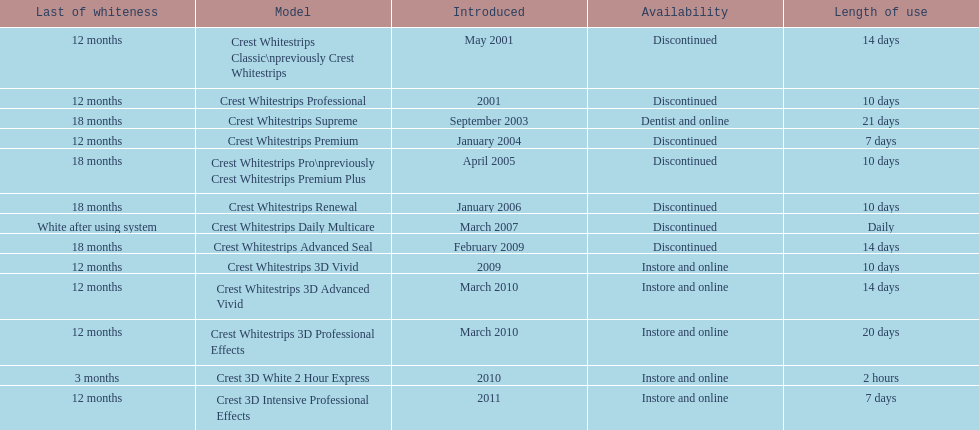How many products have been discontinued? 7. 